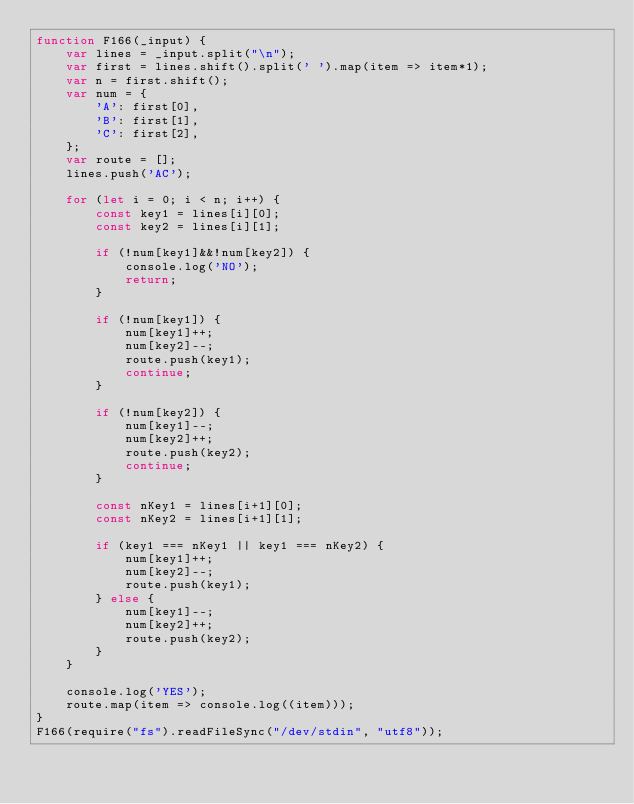<code> <loc_0><loc_0><loc_500><loc_500><_JavaScript_>function F166(_input) {
    var lines = _input.split("\n");
    var first = lines.shift().split(' ').map(item => item*1);
    var n = first.shift();
    var num = {
        'A': first[0],
        'B': first[1],
        'C': first[2],
    };
    var route = [];
    lines.push('AC');

    for (let i = 0; i < n; i++) {
        const key1 = lines[i][0];
        const key2 = lines[i][1];

        if (!num[key1]&&!num[key2]) {
            console.log('NO');
            return;
        }

        if (!num[key1]) {
            num[key1]++;
            num[key2]--;
            route.push(key1);
            continue;
        }

        if (!num[key2]) {
            num[key1]--;
            num[key2]++;
            route.push(key2);
            continue;
        }

        const nKey1 = lines[i+1][0];
        const nKey2 = lines[i+1][1];

        if (key1 === nKey1 || key1 === nKey2) {
            num[key1]++;
            num[key2]--;
            route.push(key1);
        } else {
            num[key1]--;
            num[key2]++;
            route.push(key2);
        }
    }

    console.log('YES');
    route.map(item => console.log((item)));
}
F166(require("fs").readFileSync("/dev/stdin", "utf8"));
</code> 